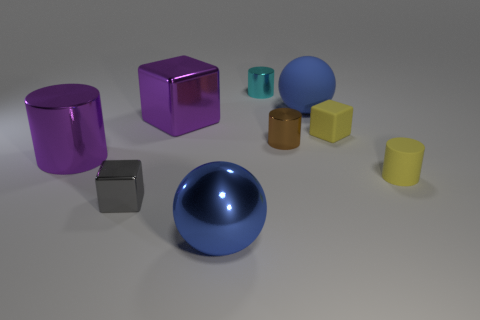Are there any purple metallic blocks that have the same size as the rubber cylinder?
Provide a succinct answer. No. There is a large blue object that is to the right of the brown metallic cylinder; is its shape the same as the large blue shiny object?
Give a very brief answer. Yes. Does the tiny cyan shiny object have the same shape as the brown shiny thing?
Provide a short and direct response. Yes. Is there another object of the same shape as the small gray thing?
Offer a very short reply. Yes. There is a small object that is on the left side of the big thing in front of the yellow rubber cylinder; what shape is it?
Keep it short and to the point. Cube. What color is the small object behind the yellow block?
Keep it short and to the point. Cyan. What is the size of the gray thing that is the same material as the brown thing?
Your answer should be very brief. Small. There is another matte object that is the same shape as the cyan thing; what size is it?
Your answer should be very brief. Small. Is there a tiny green metal cylinder?
Provide a succinct answer. No. How many objects are cylinders to the left of the tiny gray thing or cyan things?
Keep it short and to the point. 2. 